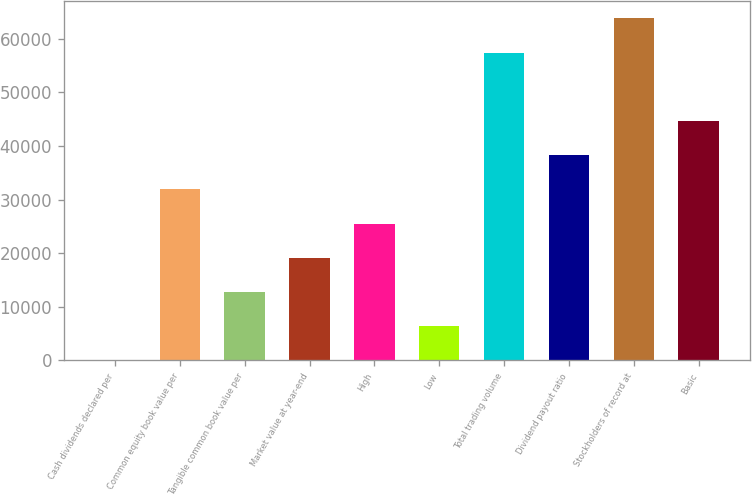<chart> <loc_0><loc_0><loc_500><loc_500><bar_chart><fcel>Cash dividends declared per<fcel>Common equity book value per<fcel>Tangible common book value per<fcel>Market value at year-end<fcel>High<fcel>Low<fcel>Total trading volume<fcel>Dividend payout ratio<fcel>Stockholders of record at<fcel>Basic<nl><fcel>0.1<fcel>31907.5<fcel>12763.1<fcel>19144.6<fcel>25526.1<fcel>6381.59<fcel>57433.5<fcel>38289<fcel>63815<fcel>44670.5<nl></chart> 